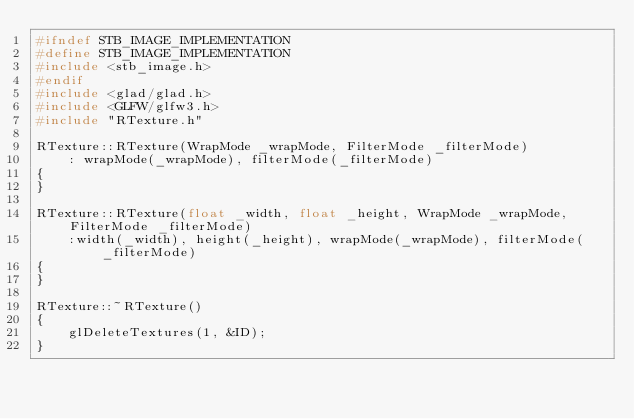Convert code to text. <code><loc_0><loc_0><loc_500><loc_500><_C++_>#ifndef STB_IMAGE_IMPLEMENTATION
#define STB_IMAGE_IMPLEMENTATION
#include <stb_image.h>
#endif
#include <glad/glad.h>
#include <GLFW/glfw3.h>
#include "RTexture.h"

RTexture::RTexture(WrapMode _wrapMode, FilterMode _filterMode)
	: wrapMode(_wrapMode), filterMode(_filterMode)
{
}

RTexture::RTexture(float _width, float _height, WrapMode _wrapMode, FilterMode _filterMode)
	:width(_width), height(_height), wrapMode(_wrapMode), filterMode(_filterMode)
{
}

RTexture::~RTexture()
{
	glDeleteTextures(1, &ID);
}
</code> 